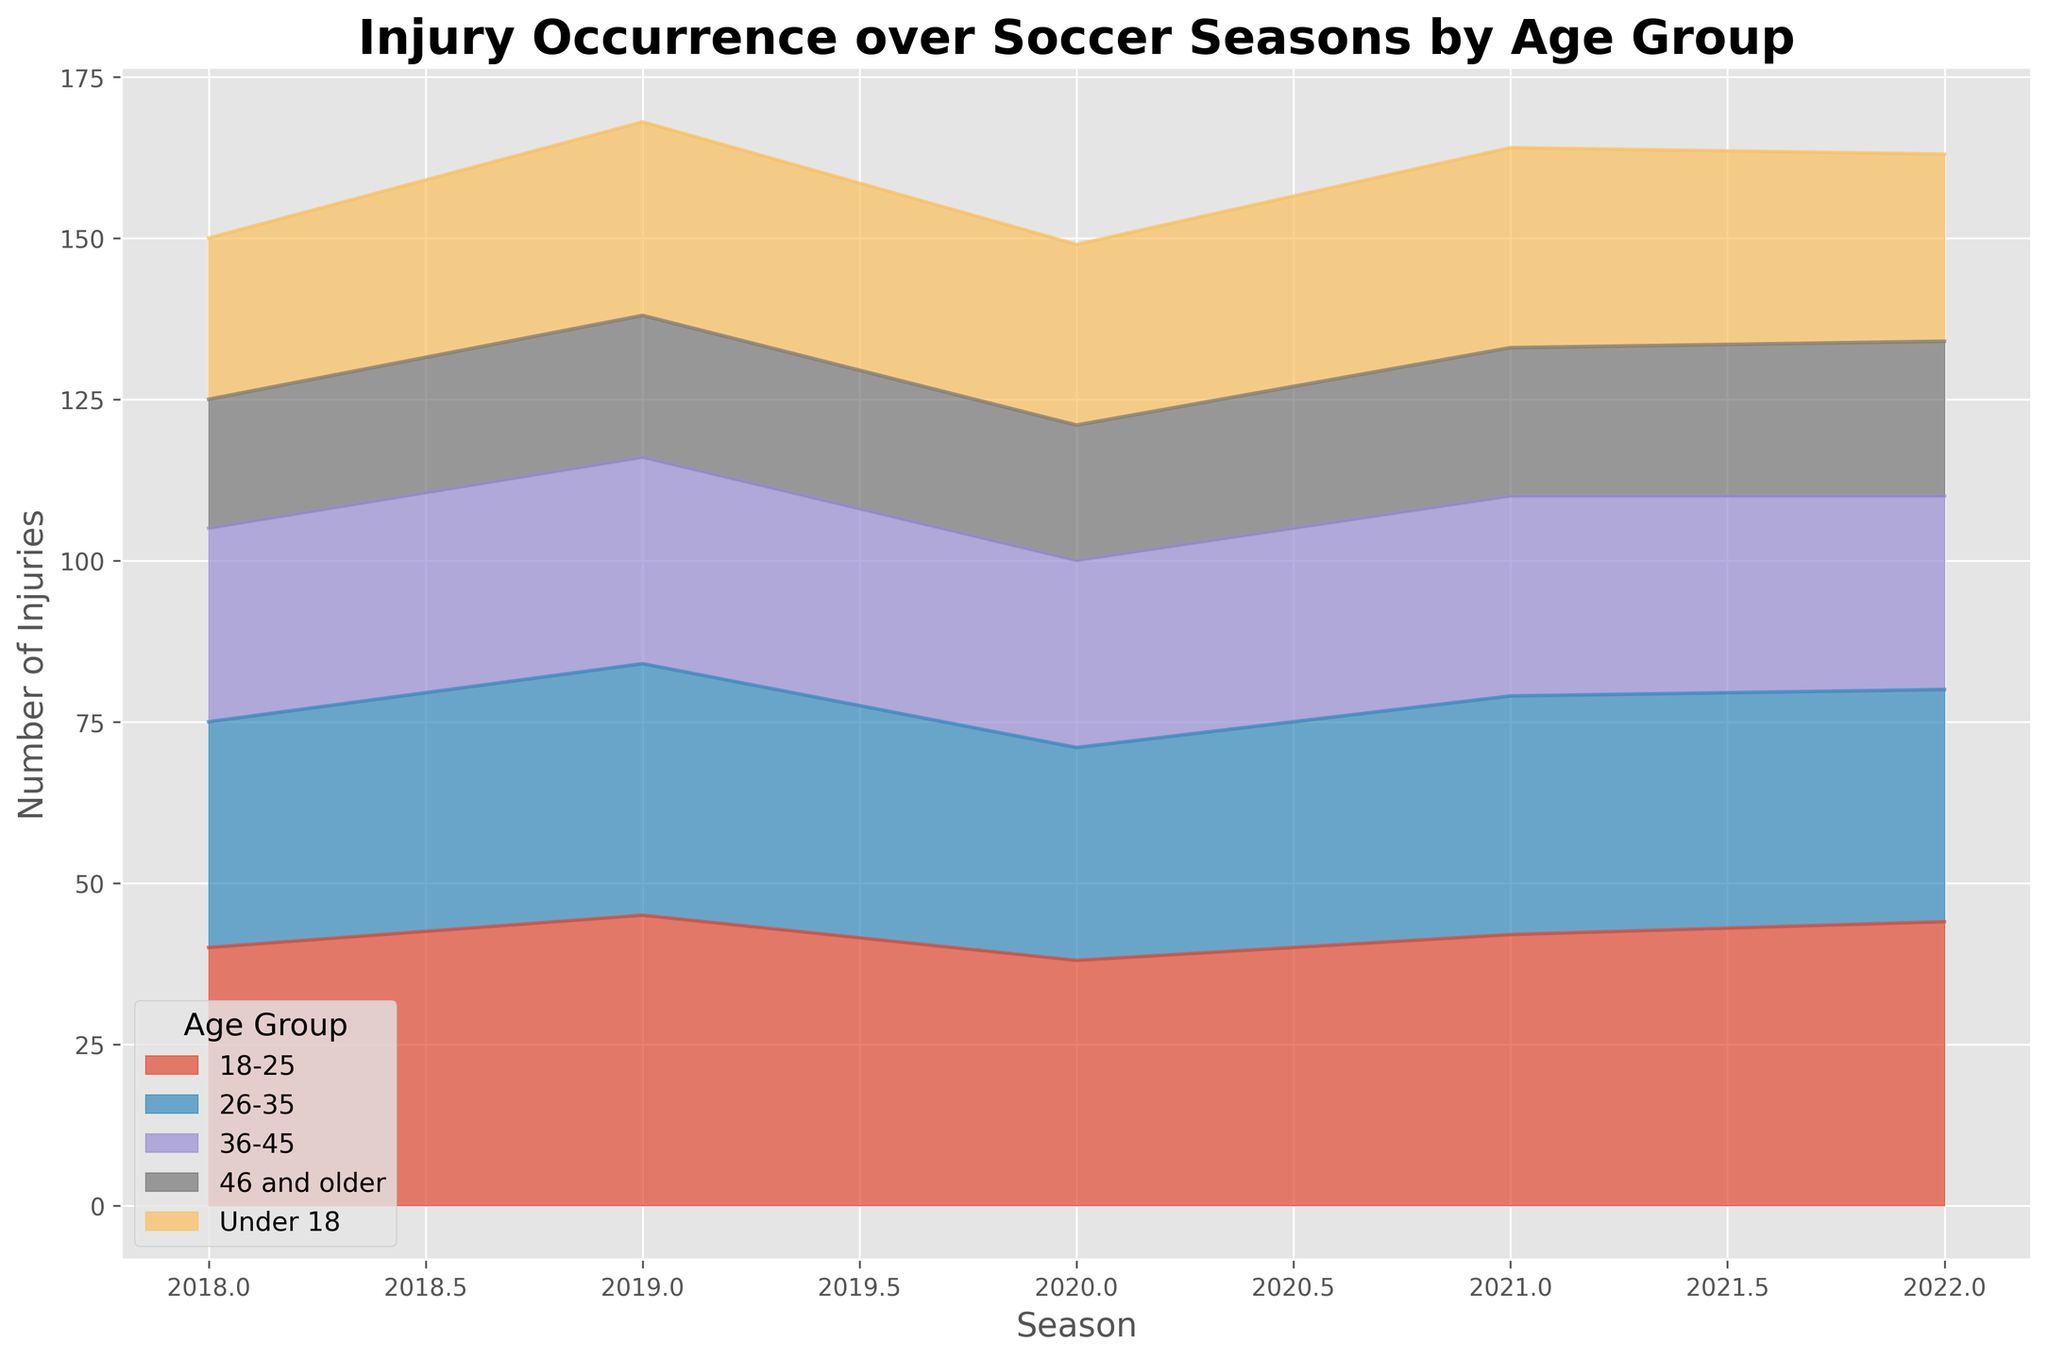How did the number of injuries for the "Under 18" age group change from 2018 to 2022? We observe that the number of injuries in the "Under 18" age group increased from 25 in 2018 to 29 in 2022.
Answer: Increased by 4 In which season did the "36-45" age group experience the highest number of injuries? By looking at the height of the area corresponding to the "36-45" age group, the highest value appears in 2019 with 32 injuries.
Answer: 2019 Compare the total number of injuries combined for all age groups in the 2018 and 2022 seasons. Summing the injuries for all age groups in 2018 (25 + 40 + 35 + 30 + 20 = 150) and for 2022 (29 + 44 + 36 + 30 + 24 = 163) shows that total injuries increased from 150 to 163.
Answer: 2018: 150, 2022: 163 Which age group consistently had the highest number of injuries during the given seasons? By observing the layers, the "18-25" age group consistently has the largest area, indicating the highest number of injuries across all seasons.
Answer: 18-25 What was the trend of injuries for the "26-35" age group from 2018 to 2022? The "26-35" age group started with 35 injuries in 2018 and varied slightly over the seasons, ending at 36 injuries in 2022. It shows a small overall increase.
Answer: Slight increase During which season was the total number of injuries highest for all age groups combined? Checking each season's sum: 2018 (150), 2019 (168), 2020 (149), 2021 (164), and 2022 (163) reveals that 2019 had the highest combined total number of injuries.
Answer: 2019 For which age group did the number of injuries remain relatively stable over the seasons? Observing each group's fluctuations, the "46 and older" age group shows a stable trend, with injuries only slightly increasing from 20 in 2018 to 24 in 2022.
Answer: 46 and older 